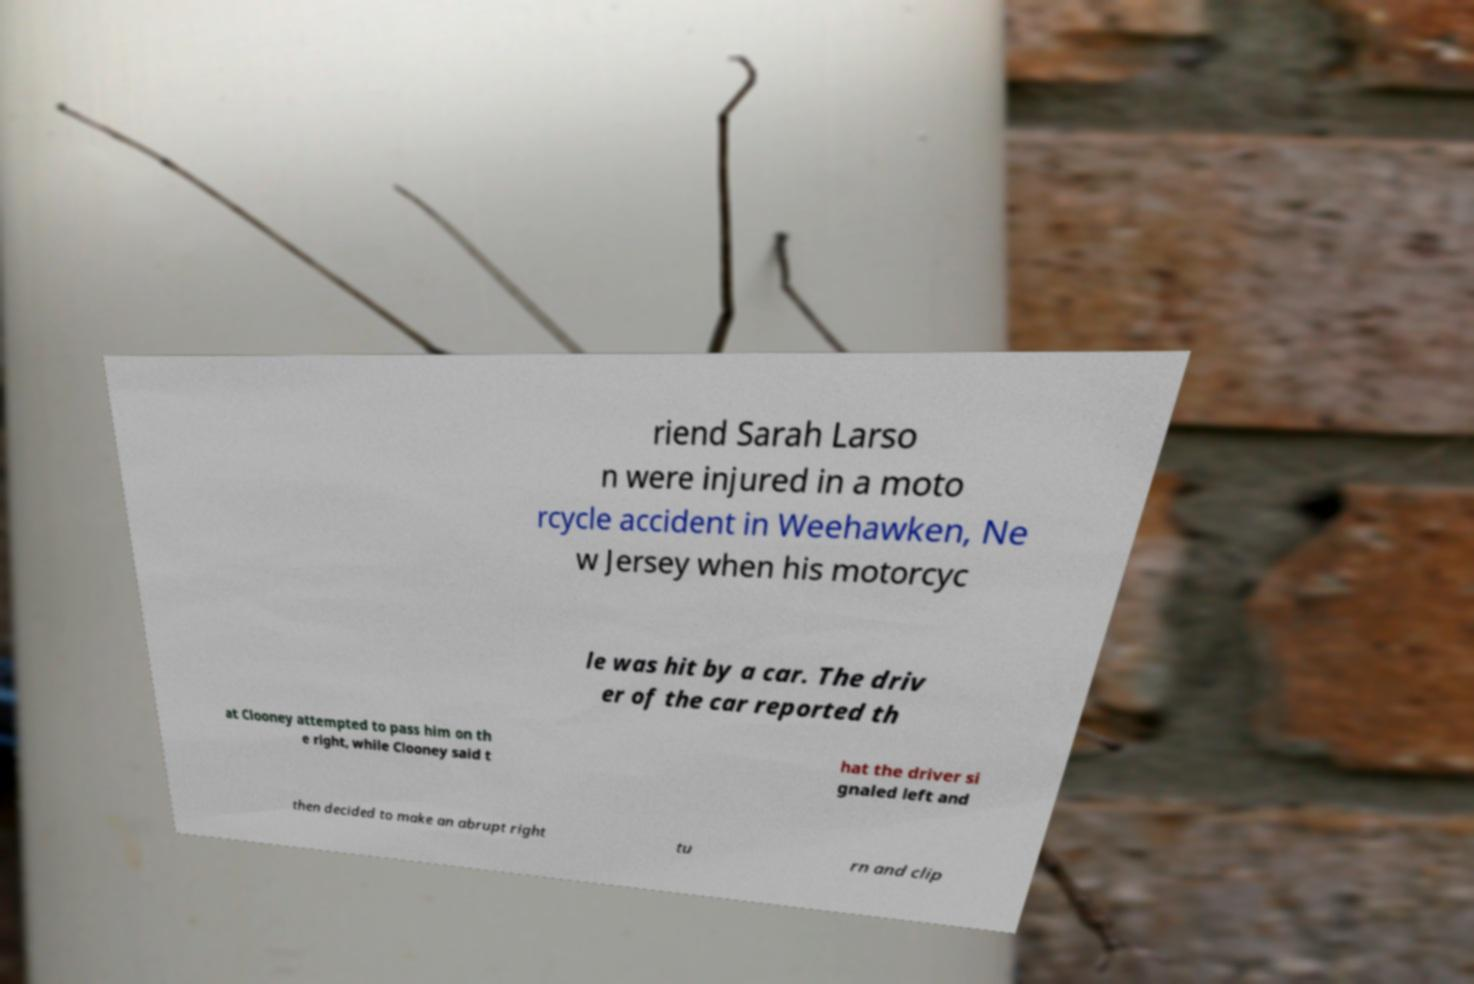What messages or text are displayed in this image? I need them in a readable, typed format. riend Sarah Larso n were injured in a moto rcycle accident in Weehawken, Ne w Jersey when his motorcyc le was hit by a car. The driv er of the car reported th at Clooney attempted to pass him on th e right, while Clooney said t hat the driver si gnaled left and then decided to make an abrupt right tu rn and clip 